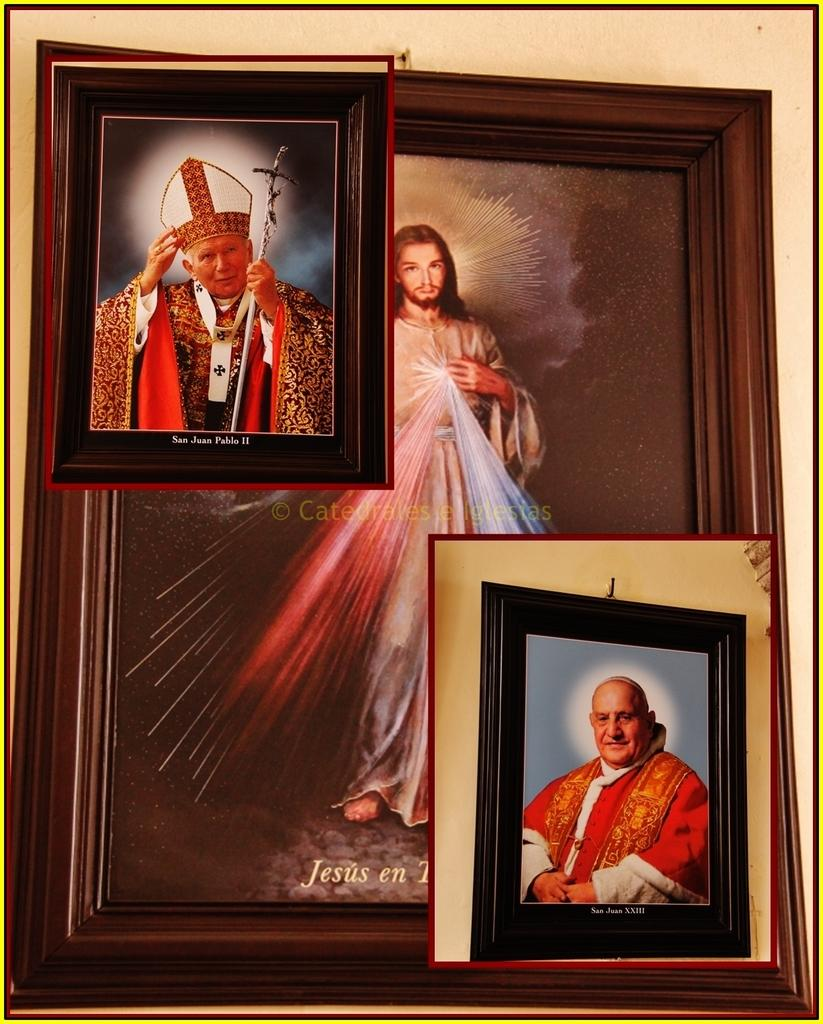<image>
Give a short and clear explanation of the subsequent image. A painting showing San Juan Pablo II is surrounded by a black background. 